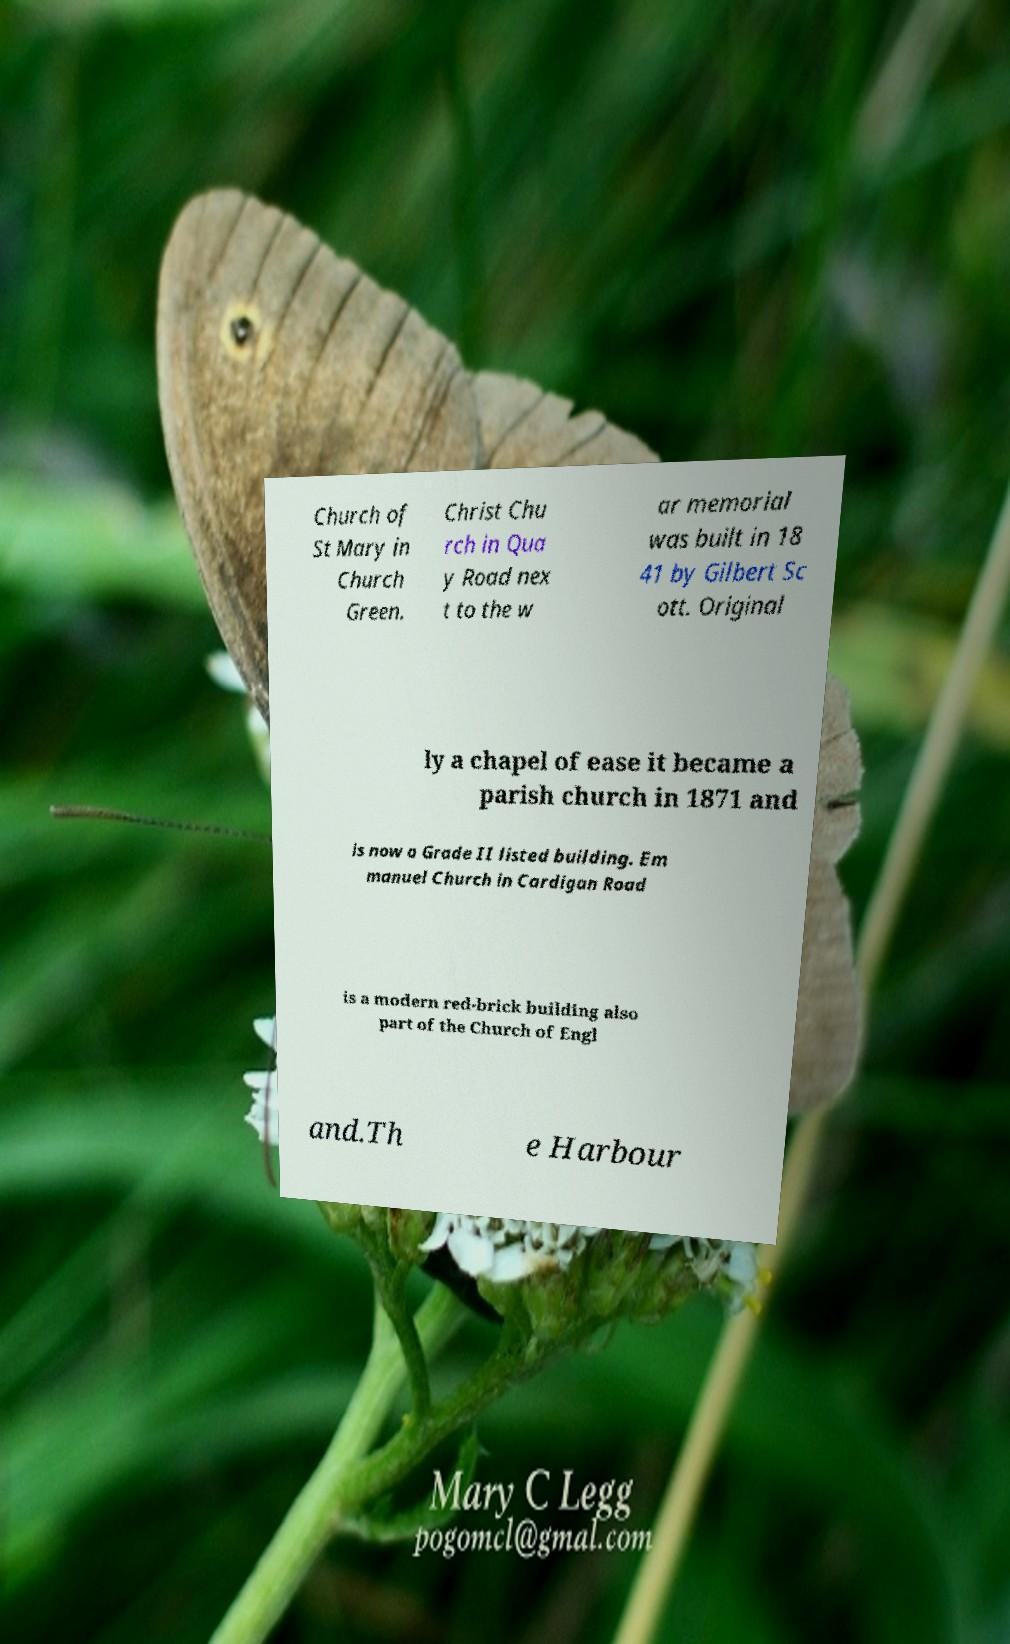There's text embedded in this image that I need extracted. Can you transcribe it verbatim? Church of St Mary in Church Green. Christ Chu rch in Qua y Road nex t to the w ar memorial was built in 18 41 by Gilbert Sc ott. Original ly a chapel of ease it became a parish church in 1871 and is now a Grade II listed building. Em manuel Church in Cardigan Road is a modern red-brick building also part of the Church of Engl and.Th e Harbour 